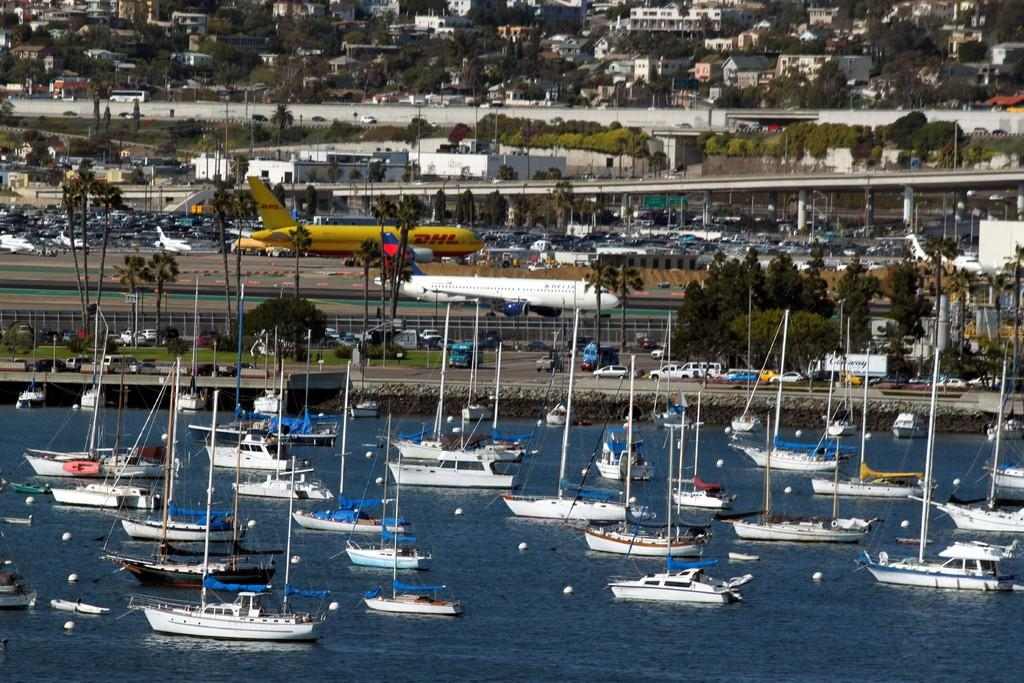What can be seen at the bottom side of the image? There are ships on the water at the bottom side of the image. What is visible in the background of the image? In the background of the image, there are vehicles, trees, poles, an aircraft, and buildings. Can you describe the types of transportation present in the image? The image features ships, vehicles, and an aircraft as modes of transportation. What type of amusement can be seen in the image? There is no amusement present in the image; it features ships, vehicles, trees, poles, an aircraft, and buildings. What color is the skirt worn by the tree in the image? There is no tree wearing a skirt in the image; trees are natural vegetation. 